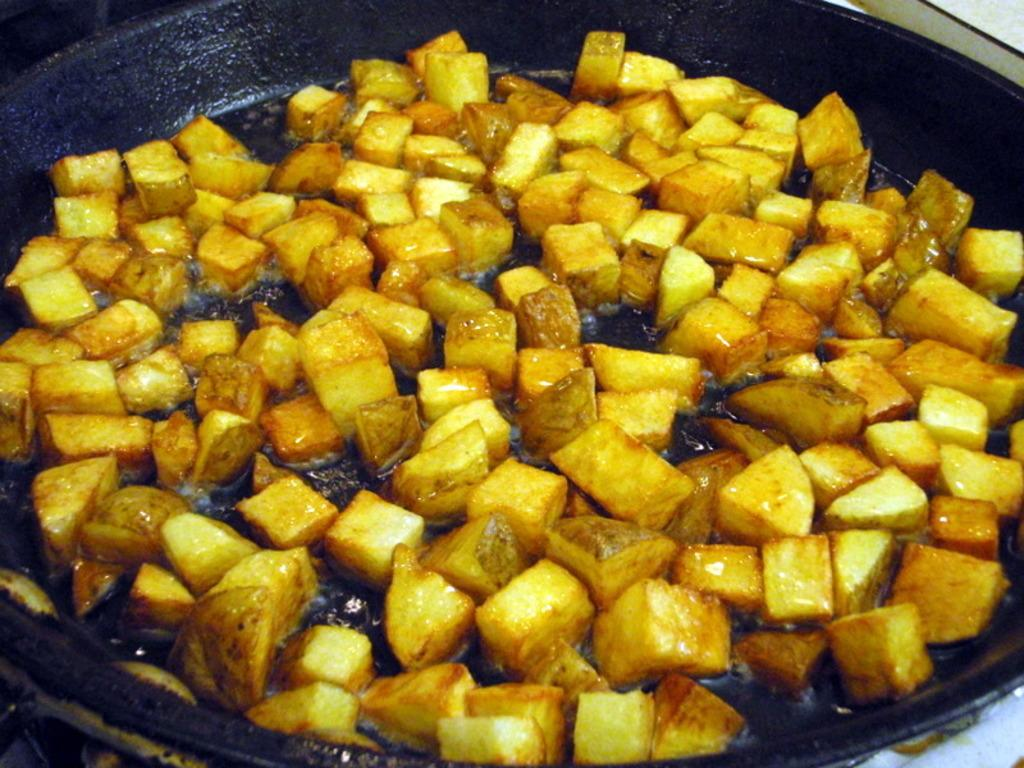What is the main object in the image? There is a frying pan in the image. What is inside the frying pan? There is food in the frying pan. What is used to cook the food in the frying pan? There is oil in the frying pan. What type of trucks can be seen driving on the road in the image? There are no trucks or roads present in the image; it features a frying pan with food and oil. What kind of drug is being prepared in the frying pan? There is no drug present in the image; it features a frying pan with food and oil. 